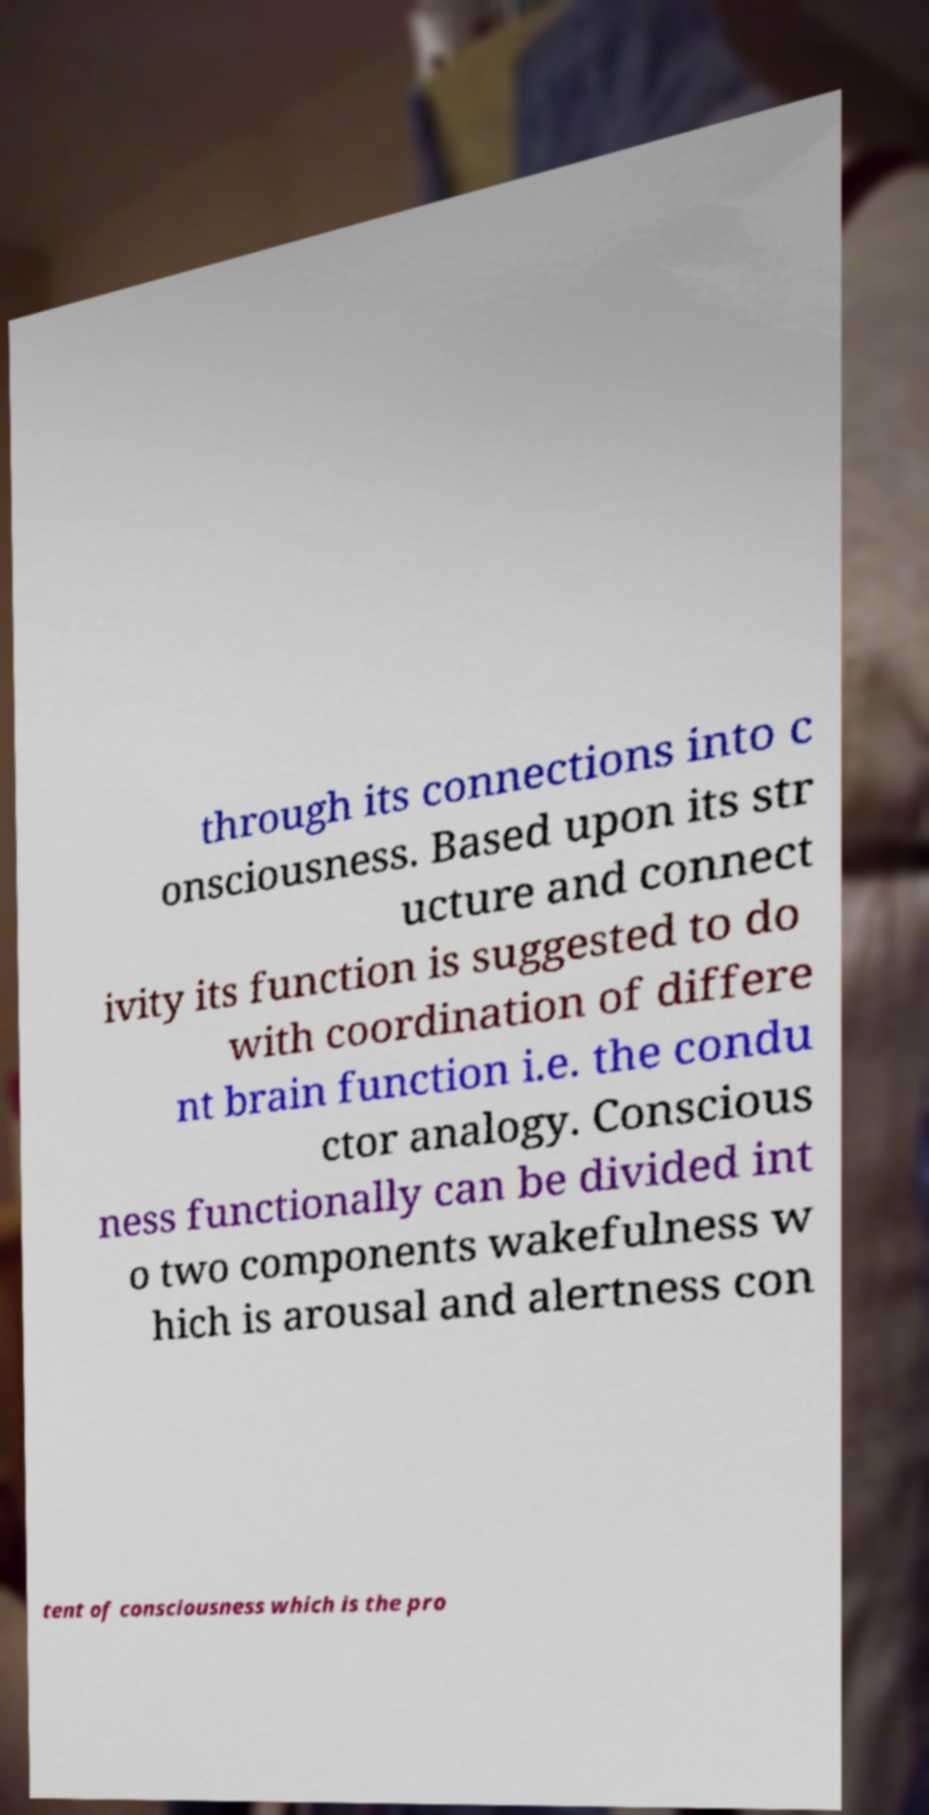Please read and relay the text visible in this image. What does it say? through its connections into c onsciousness. Based upon its str ucture and connect ivity its function is suggested to do with coordination of differe nt brain function i.e. the condu ctor analogy. Conscious ness functionally can be divided int o two components wakefulness w hich is arousal and alertness con tent of consciousness which is the pro 